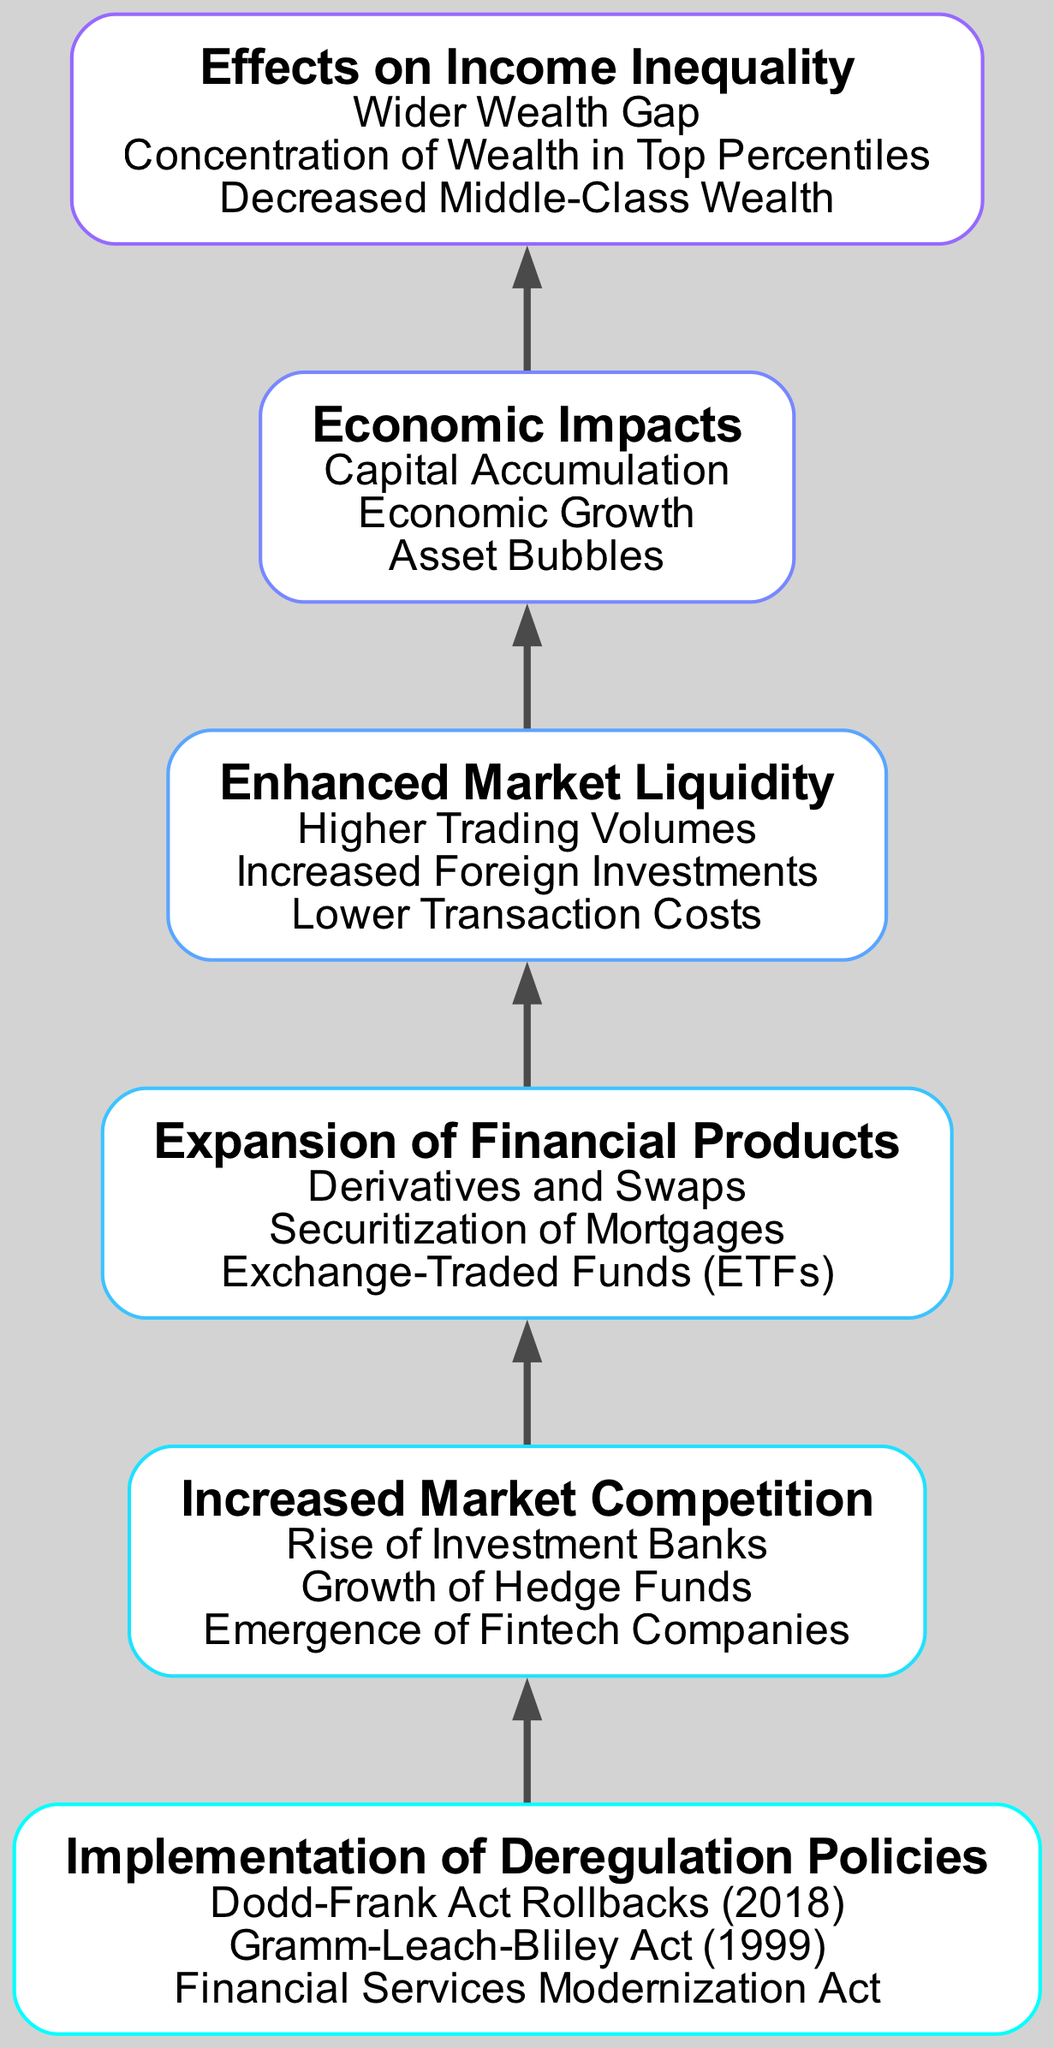What is the top node in the diagram? The top node is "Effects on Income Inequality," which is the final conclusion reached after traversing the flow of the diagram.
Answer: Effects on Income Inequality How many elements are shown in the diagram? The diagram contains six elements, which represent the key stages in the evolution of financial markets post-deregulation.
Answer: 6 What does the node above "Increased Market Competition" indicate? The node above "Increased Market Competition" is "Implementation of Deregulation Policies," showing that deregulation leads to increased competition in financial markets.
Answer: Implementation of Deregulation Policies What are the three details listed under "Economic Impacts"? The three details are "Capital Accumulation," "Economic Growth," and "Asset Bubbles," highlighting the economic effects resulting from the financial market changes.
Answer: Capital Accumulation, Economic Growth, Asset Bubbles Which element serves as the main cause for the "Wider Wealth Gap"? The main cause is identified as "Economic Impacts," as it leads to a wider wealth gap among different income groups as reflected in the final node of the diagram.
Answer: Economic Impacts What relationship exists between "Enhanced Market Liquidity" and "Economic Impacts"? "Enhanced Market Liquidity" directly influences "Economic Impacts," indicating that improved liquidity can lead to various economic effects such as growth and capital accumulation.
Answer: Direct influence Which two nodes are directly connected to "Expansion of Financial Products"? "Increased Market Competition" and "Enhanced Market Liquidity" are the two nodes directly connected to "Expansion of Financial Products," indicating their influence on the types of financial products available.
Answer: Increased Market Competition, Enhanced Market Liquidity What node comes immediately below "Effects on Income Inequality"? The node immediately below "Effects on Income Inequality" is "Economic Impacts," indicating that income inequality results from the economic changes following deregulation.
Answer: Economic Impacts How does "Implementation of Deregulation Policies" affect "Increased Market Competition"? "Implementation of Deregulation Policies" facilitates "Increased Market Competition" by removing barriers in the financial sector, encouraging the entrance of new players.
Answer: Facilitates increased competition 